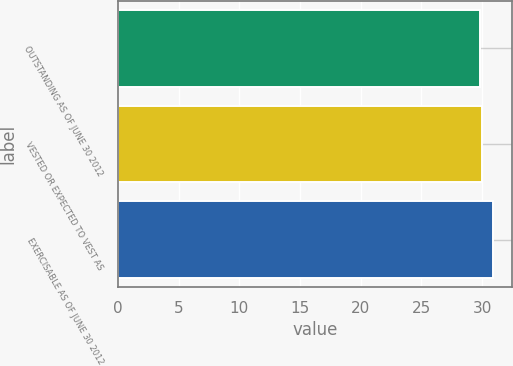Convert chart. <chart><loc_0><loc_0><loc_500><loc_500><bar_chart><fcel>OUTSTANDING AS OF JUNE 30 2012<fcel>VESTED OR EXPECTED TO VEST AS<fcel>EXERCISABLE AS OF JUNE 30 2012<nl><fcel>29.85<fcel>29.96<fcel>30.93<nl></chart> 